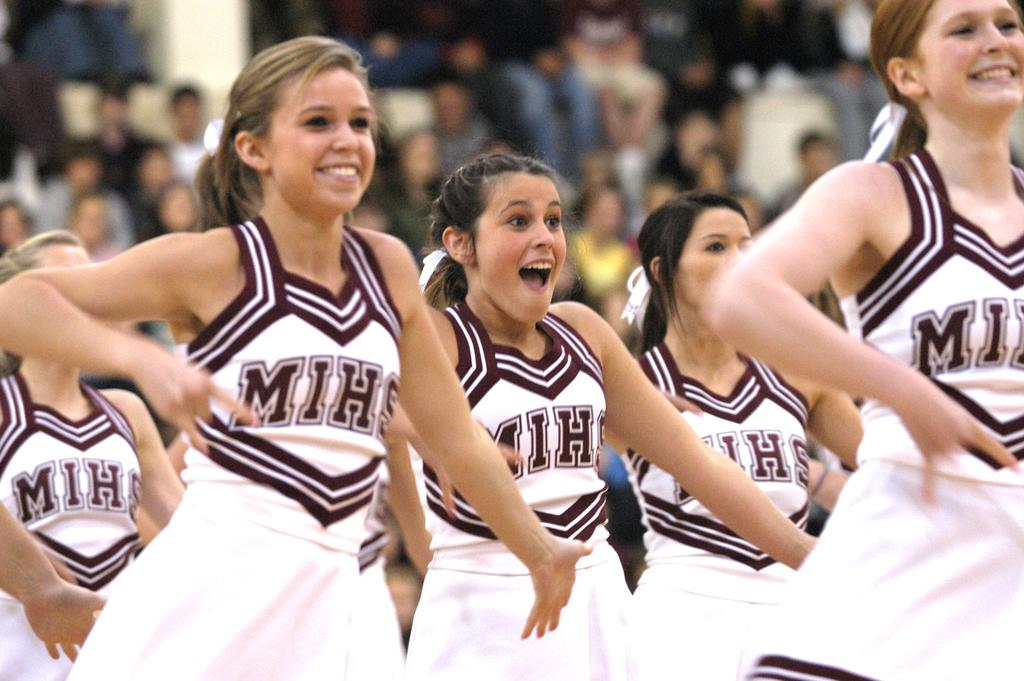<image>
Summarize the visual content of the image. A cheerleader squad performing with MIHS on their tops. 